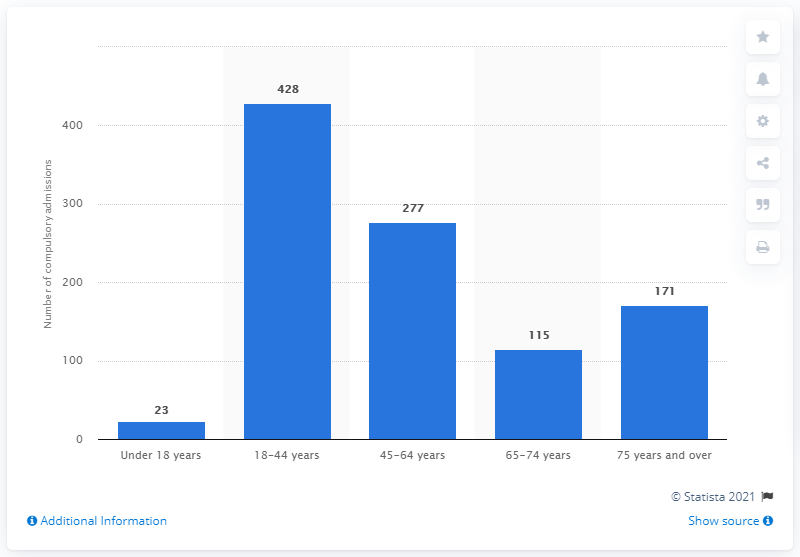Mention a couple of crucial points in this snapshot. In 2019/2020, a total of 428 individuals aged between 18 and 44 were admitted to a mental health hospital in Northern Ireland. 